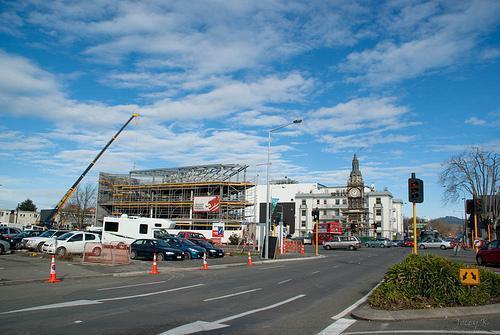How many traffic cones are on this street?
Give a very brief answer. 4. 